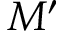Convert formula to latex. <formula><loc_0><loc_0><loc_500><loc_500>M ^ { \prime }</formula> 